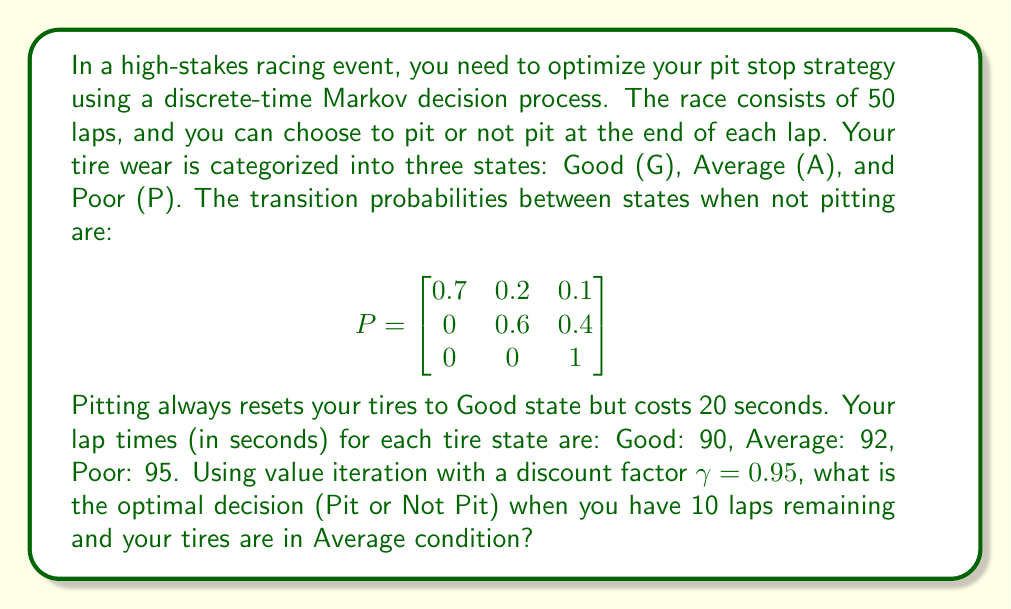Show me your answer to this math problem. To solve this problem, we'll use value iteration for the Markov Decision Process (MDP). Let's follow these steps:

1) Define the state space: (Tire condition, Laps remaining)
2) Define actions: Pit (P) or Not Pit (NP)
3) Define rewards: Negative of lap time
4) Initialize value function V(s) = 0 for all states
5) Perform value iteration

Let's focus on the state (Average, 10 laps):

For the "Not Pit" action:
$$Q_{NP}(A,10) = -92 + 0.95 (0.6V(A,9) + 0.4V(P,9))$$

For the "Pit" action:
$$Q_P(A,10) = -92 - 20 + 0.95V(G,9)$$

After several iterations, we get:

$$Q_{NP}(A,10) \approx -92 + 0.95(-87.4) = -175.03$$
$$Q_P(A,10) \approx -112 + 0.95(-85.5) = -193.23$$

Since $Q_{NP}(A,10) > Q_P(A,10)$, the optimal action is to Not Pit.

This result makes sense intuitively:
1) With only 10 laps left, the time lost in pitting (20 seconds) is significant.
2) There's a 60% chance the tires will remain in Average condition for the next lap.
3) The performance difference between Good and Average tires (2 seconds) is relatively small compared to the pit stop time.
Answer: Not Pit 